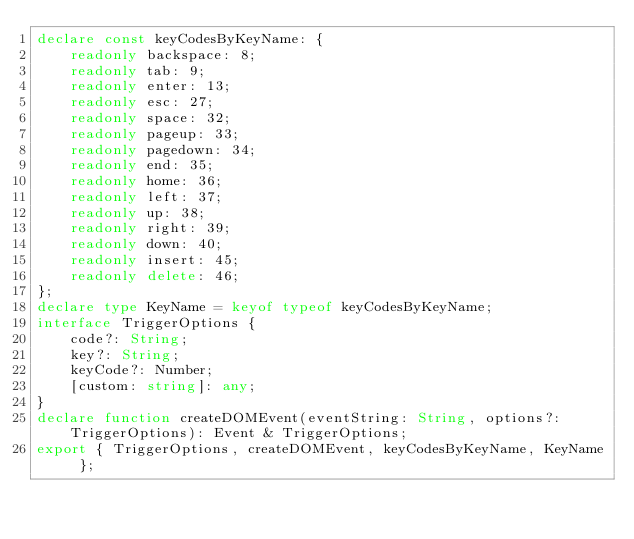Convert code to text. <code><loc_0><loc_0><loc_500><loc_500><_TypeScript_>declare const keyCodesByKeyName: {
    readonly backspace: 8;
    readonly tab: 9;
    readonly enter: 13;
    readonly esc: 27;
    readonly space: 32;
    readonly pageup: 33;
    readonly pagedown: 34;
    readonly end: 35;
    readonly home: 36;
    readonly left: 37;
    readonly up: 38;
    readonly right: 39;
    readonly down: 40;
    readonly insert: 45;
    readonly delete: 46;
};
declare type KeyName = keyof typeof keyCodesByKeyName;
interface TriggerOptions {
    code?: String;
    key?: String;
    keyCode?: Number;
    [custom: string]: any;
}
declare function createDOMEvent(eventString: String, options?: TriggerOptions): Event & TriggerOptions;
export { TriggerOptions, createDOMEvent, keyCodesByKeyName, KeyName };
</code> 